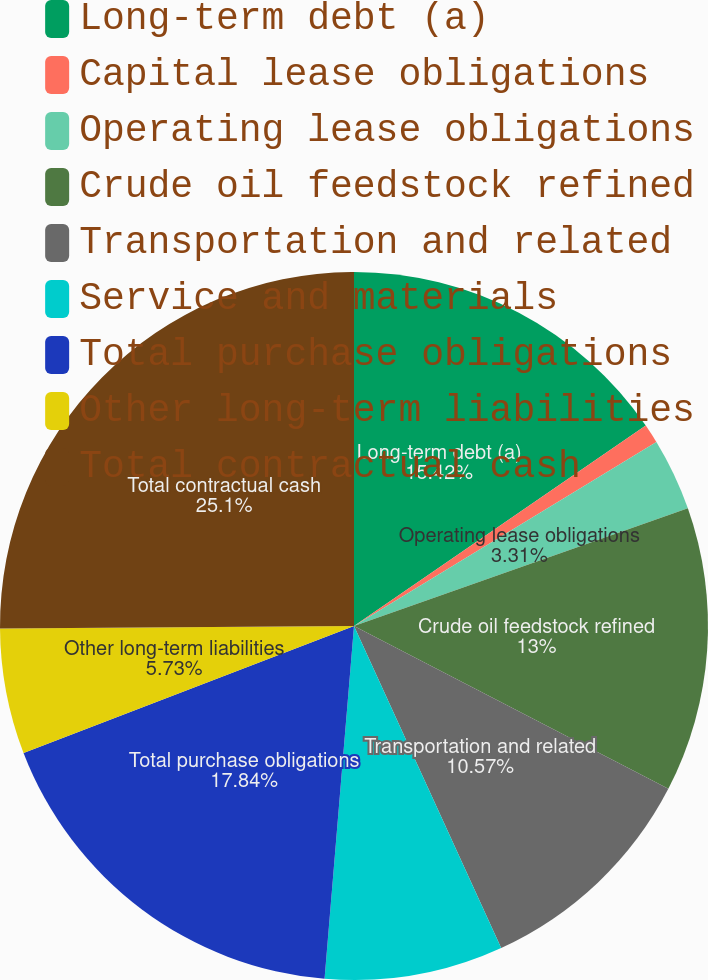Convert chart to OTSL. <chart><loc_0><loc_0><loc_500><loc_500><pie_chart><fcel>Long-term debt (a)<fcel>Capital lease obligations<fcel>Operating lease obligations<fcel>Crude oil feedstock refined<fcel>Transportation and related<fcel>Service and materials<fcel>Total purchase obligations<fcel>Other long-term liabilities<fcel>Total contractual cash<nl><fcel>15.42%<fcel>0.88%<fcel>3.31%<fcel>13.0%<fcel>10.57%<fcel>8.15%<fcel>17.84%<fcel>5.73%<fcel>25.11%<nl></chart> 